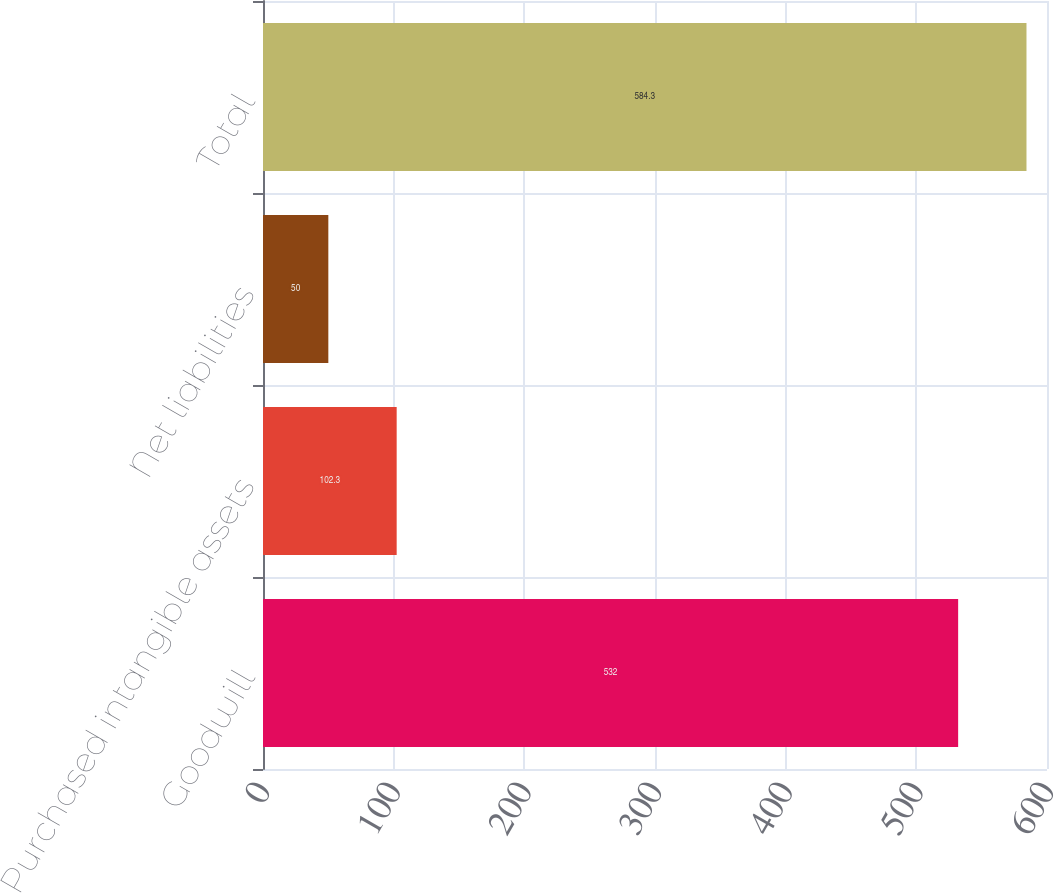Convert chart. <chart><loc_0><loc_0><loc_500><loc_500><bar_chart><fcel>Goodwill<fcel>Purchased intangible assets<fcel>Net liabilities<fcel>Total<nl><fcel>532<fcel>102.3<fcel>50<fcel>584.3<nl></chart> 